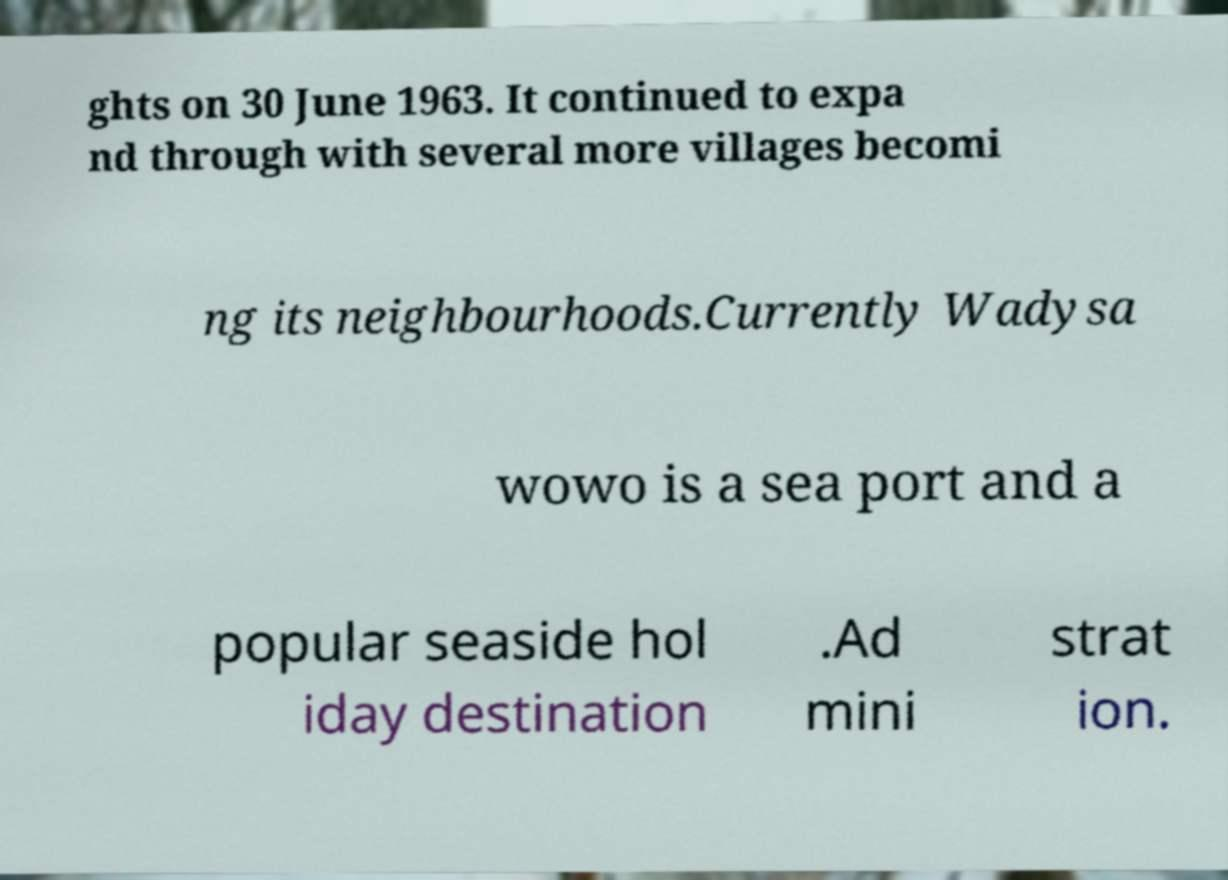Could you assist in decoding the text presented in this image and type it out clearly? ghts on 30 June 1963. It continued to expa nd through with several more villages becomi ng its neighbourhoods.Currently Wadysa wowo is a sea port and a popular seaside hol iday destination .Ad mini strat ion. 